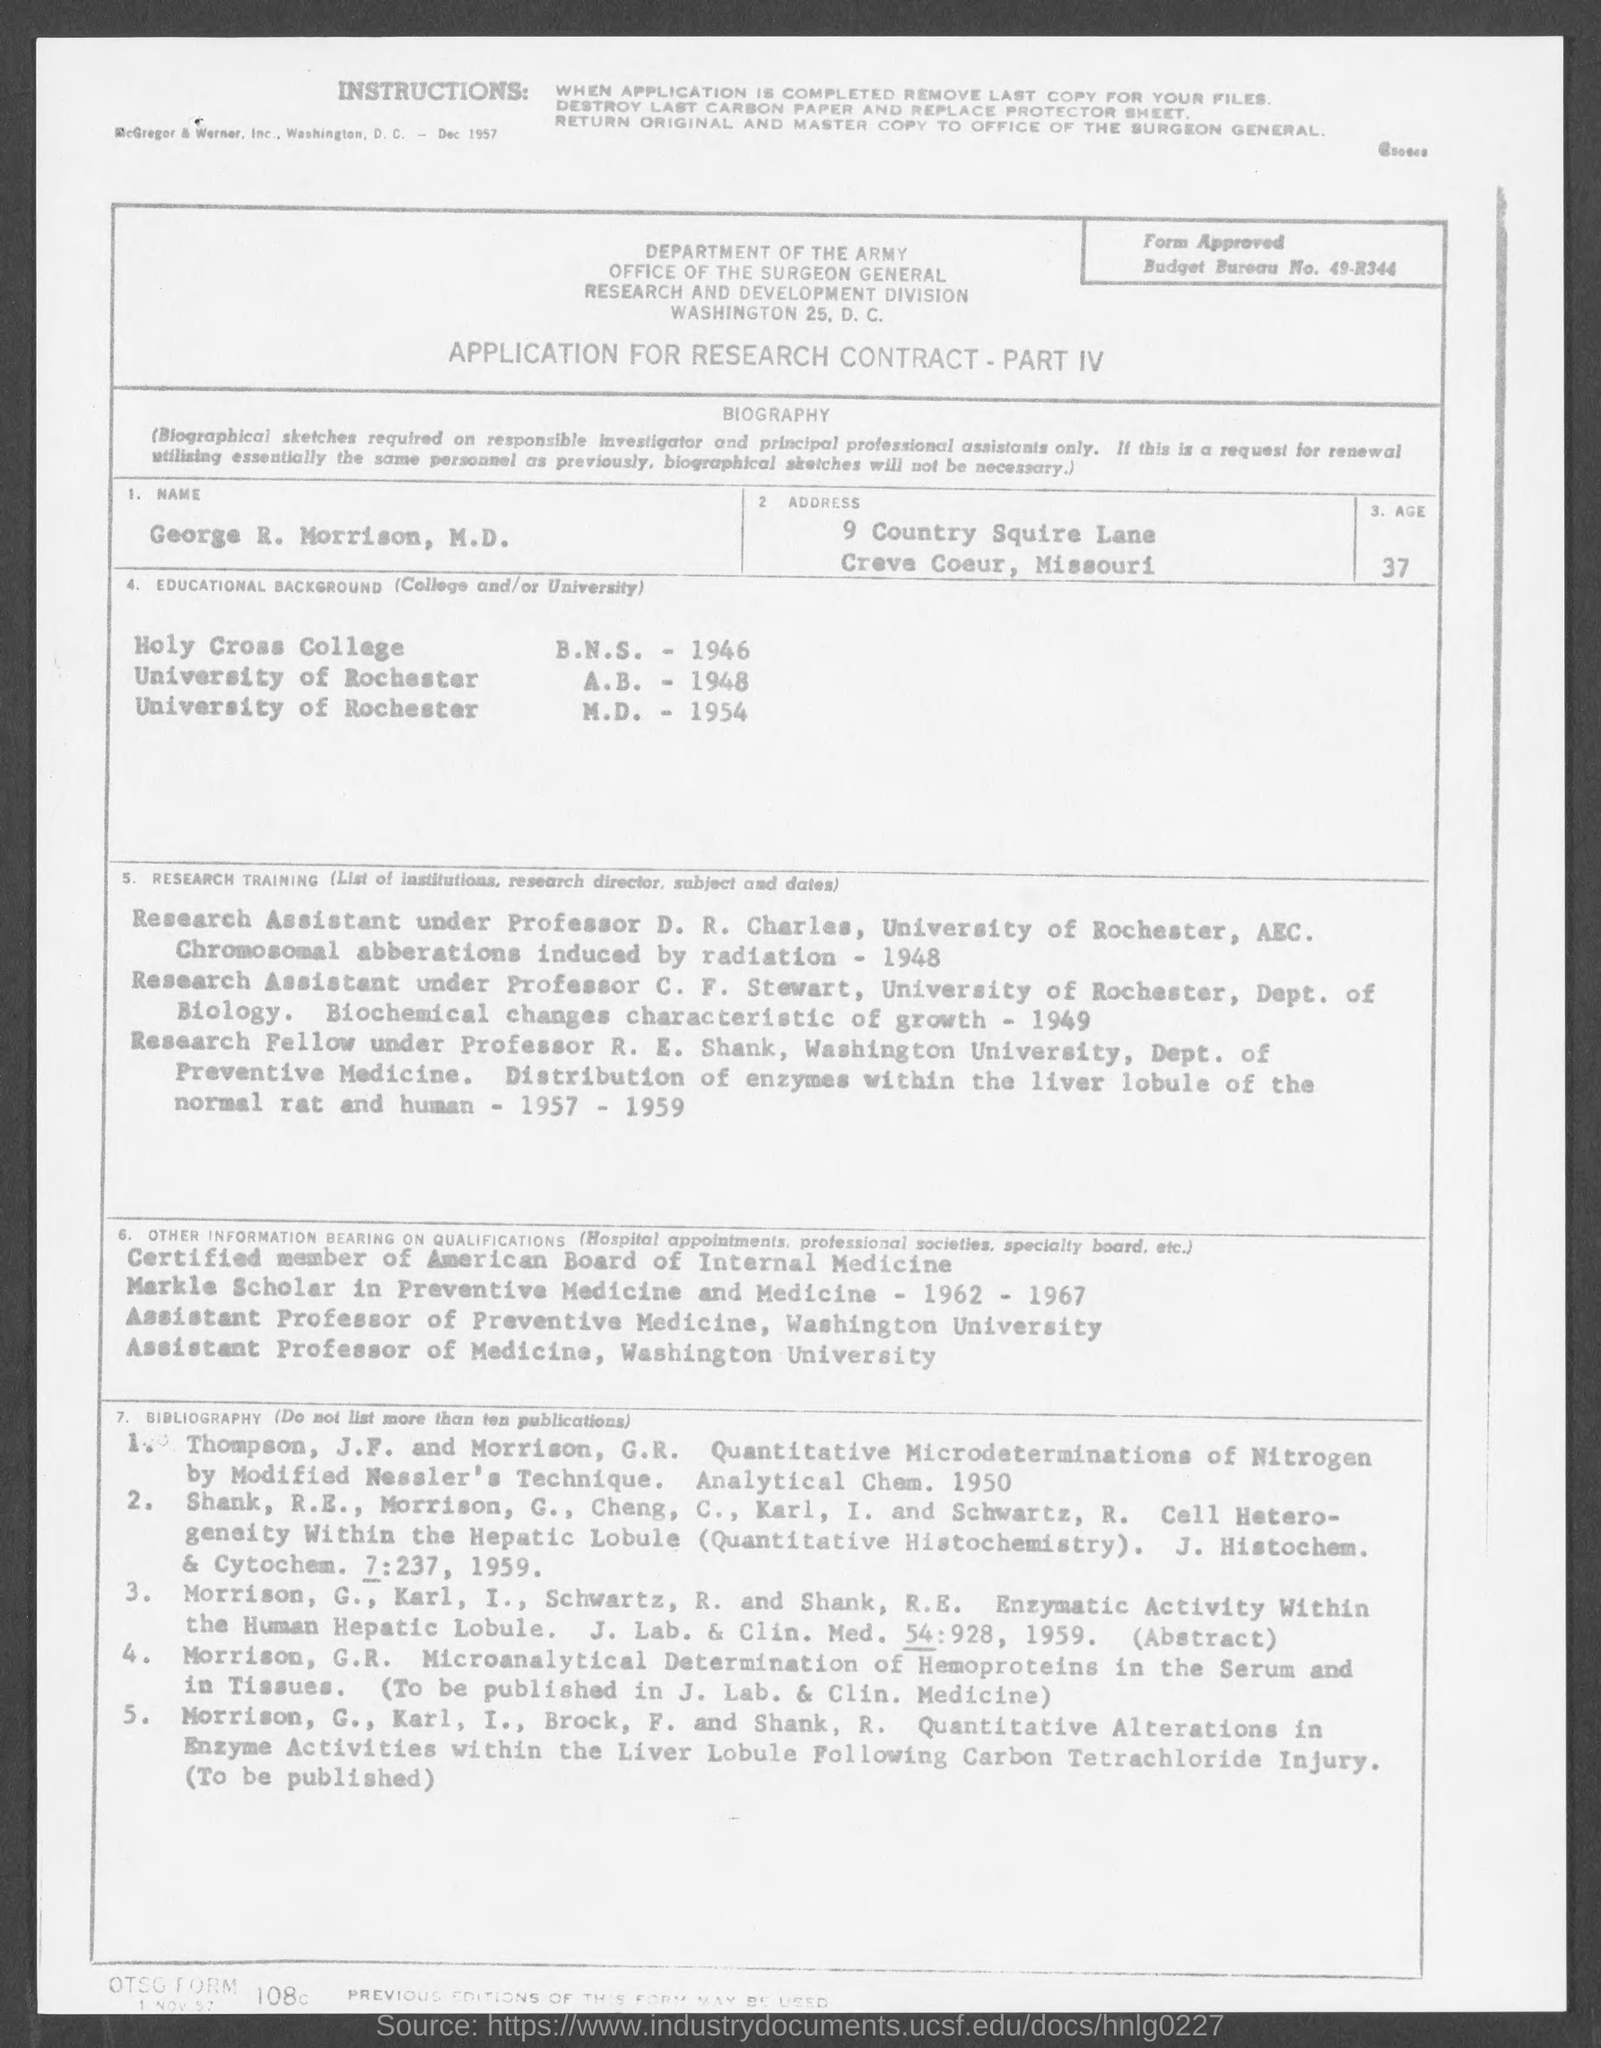What is the form about?
Your answer should be compact. APPLICATION FOR RESEARCH CONTRACT - PART IV. What is the name given?
Ensure brevity in your answer.  George R. Morrison, M.D. What is the Budget Bureau No.?
Ensure brevity in your answer.  49-R344. From which university did George R. Morrison receive his M.D.?
Provide a succinct answer. University of Rochester. Which year did George R. Morrison receive his A.B.?
Keep it short and to the point. 1948. 